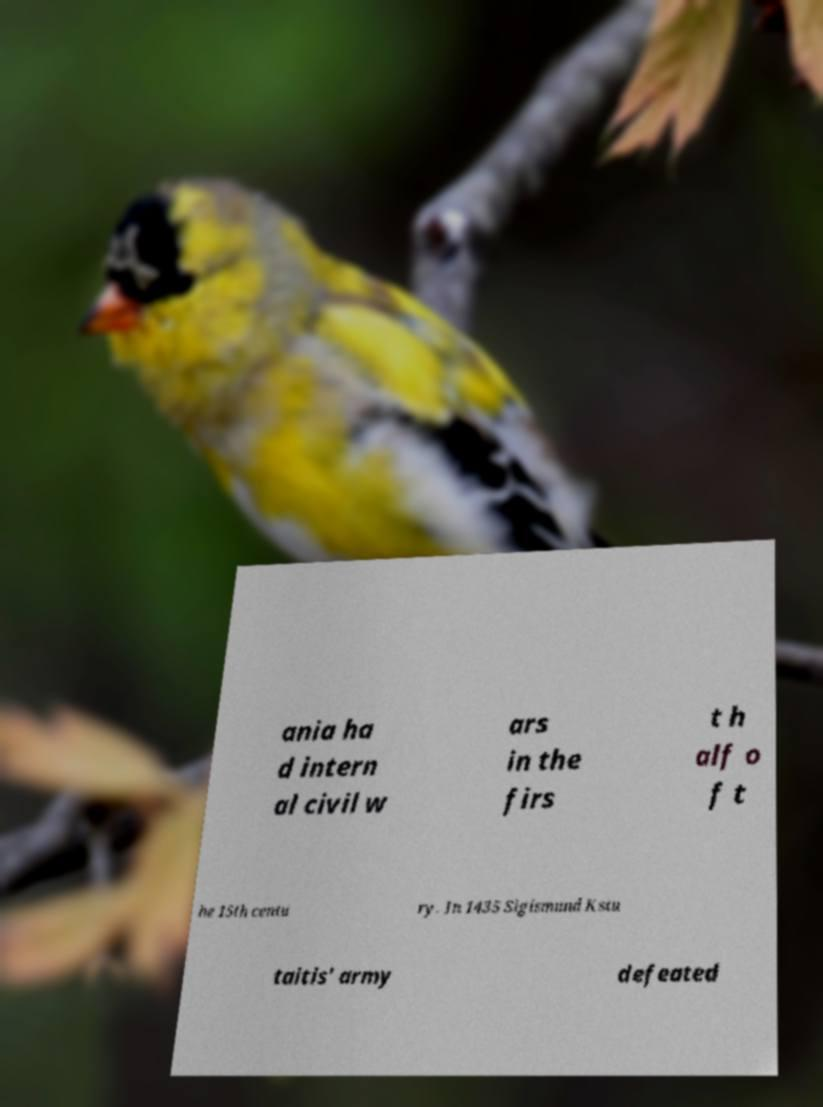I need the written content from this picture converted into text. Can you do that? ania ha d intern al civil w ars in the firs t h alf o f t he 15th centu ry. In 1435 Sigismund Kstu taitis' army defeated 